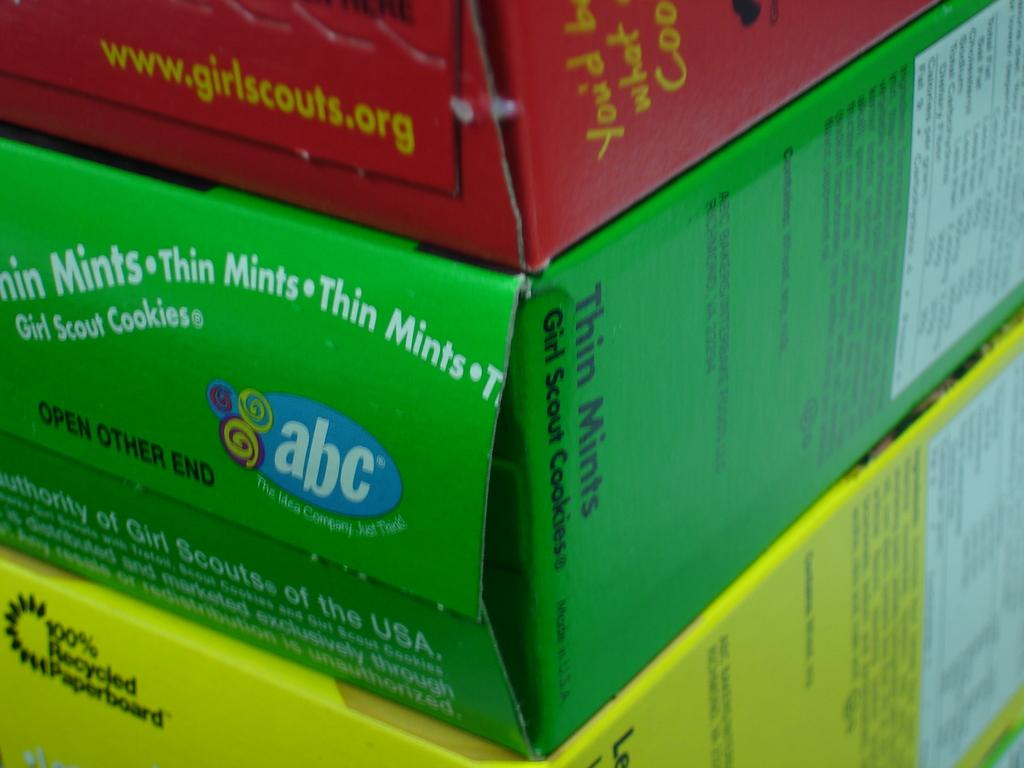<image>
Describe the image concisely. Three boxes of Girl Scout cookies stacked on top of each other 